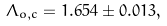<formula> <loc_0><loc_0><loc_500><loc_500>\Lambda _ { o , c } = 1 . 6 5 4 \pm 0 . 0 1 3 ,</formula> 